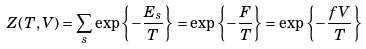<formula> <loc_0><loc_0><loc_500><loc_500>Z ( T , V ) = \sum _ { s } \exp \left \{ - \frac { E _ { s } } { T } \right \} = \exp \left \{ - \frac { F } { T } \right \} = \exp \left \{ - \frac { f V } { T } \right \}</formula> 